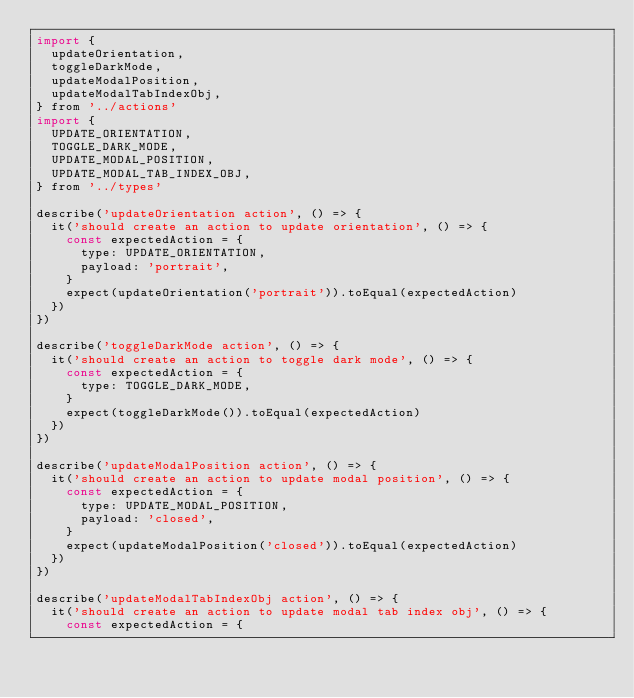Convert code to text. <code><loc_0><loc_0><loc_500><loc_500><_JavaScript_>import {
  updateOrientation,
  toggleDarkMode,
  updateModalPosition,
  updateModalTabIndexObj,
} from '../actions'
import {
  UPDATE_ORIENTATION,
  TOGGLE_DARK_MODE,
  UPDATE_MODAL_POSITION,
  UPDATE_MODAL_TAB_INDEX_OBJ,
} from '../types'

describe('updateOrientation action', () => {
  it('should create an action to update orientation', () => {
    const expectedAction = {
      type: UPDATE_ORIENTATION,
      payload: 'portrait',
    }
    expect(updateOrientation('portrait')).toEqual(expectedAction)
  })
})

describe('toggleDarkMode action', () => {
  it('should create an action to toggle dark mode', () => {
    const expectedAction = {
      type: TOGGLE_DARK_MODE,
    }
    expect(toggleDarkMode()).toEqual(expectedAction)
  })
})

describe('updateModalPosition action', () => {
  it('should create an action to update modal position', () => {
    const expectedAction = {
      type: UPDATE_MODAL_POSITION,
      payload: 'closed',
    }
    expect(updateModalPosition('closed')).toEqual(expectedAction)
  })
})

describe('updateModalTabIndexObj action', () => {
  it('should create an action to update modal tab index obj', () => {
    const expectedAction = {</code> 